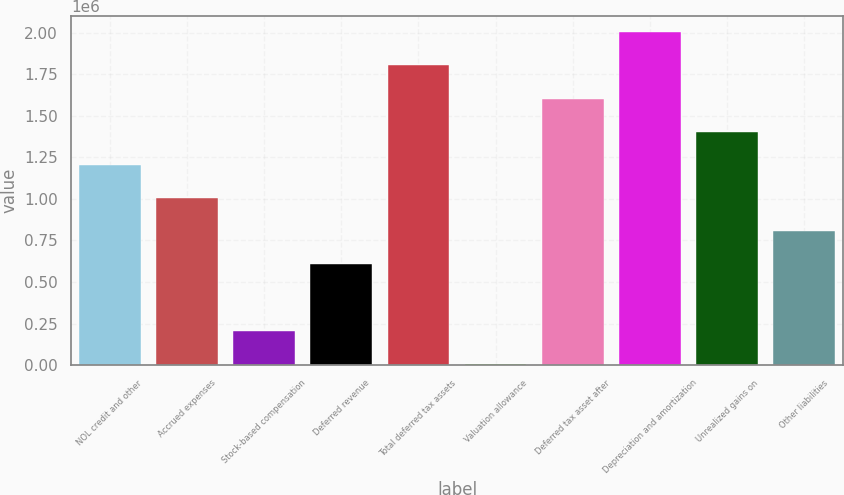Convert chart. <chart><loc_0><loc_0><loc_500><loc_500><bar_chart><fcel>NOL credit and other<fcel>Accrued expenses<fcel>Stock-based compensation<fcel>Deferred revenue<fcel>Total deferred tax assets<fcel>Valuation allowance<fcel>Deferred tax asset after<fcel>Depreciation and amortization<fcel>Unrealized gains on<fcel>Other liabilities<nl><fcel>1.20496e+06<fcel>1.00557e+06<fcel>208036<fcel>606805<fcel>1.80311e+06<fcel>8652<fcel>1.60373e+06<fcel>2.0025e+06<fcel>1.40434e+06<fcel>806189<nl></chart> 